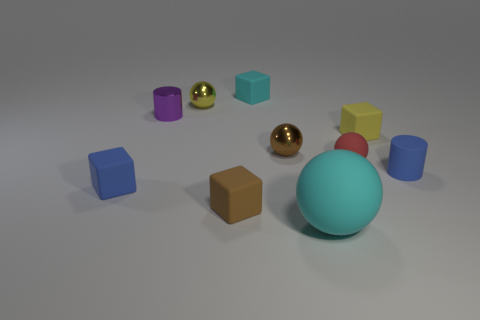Subtract all tiny cyan blocks. How many blocks are left? 3 Subtract 1 blocks. How many blocks are left? 3 Subtract all cubes. How many objects are left? 6 Add 5 metallic objects. How many metallic objects exist? 8 Subtract all purple cylinders. How many cylinders are left? 1 Subtract 0 brown cylinders. How many objects are left? 10 Subtract all cyan cubes. Subtract all red balls. How many cubes are left? 3 Subtract all blue things. Subtract all red balls. How many objects are left? 7 Add 4 matte balls. How many matte balls are left? 6 